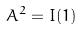<formula> <loc_0><loc_0><loc_500><loc_500>A ^ { 2 } = I ( 1 )</formula> 